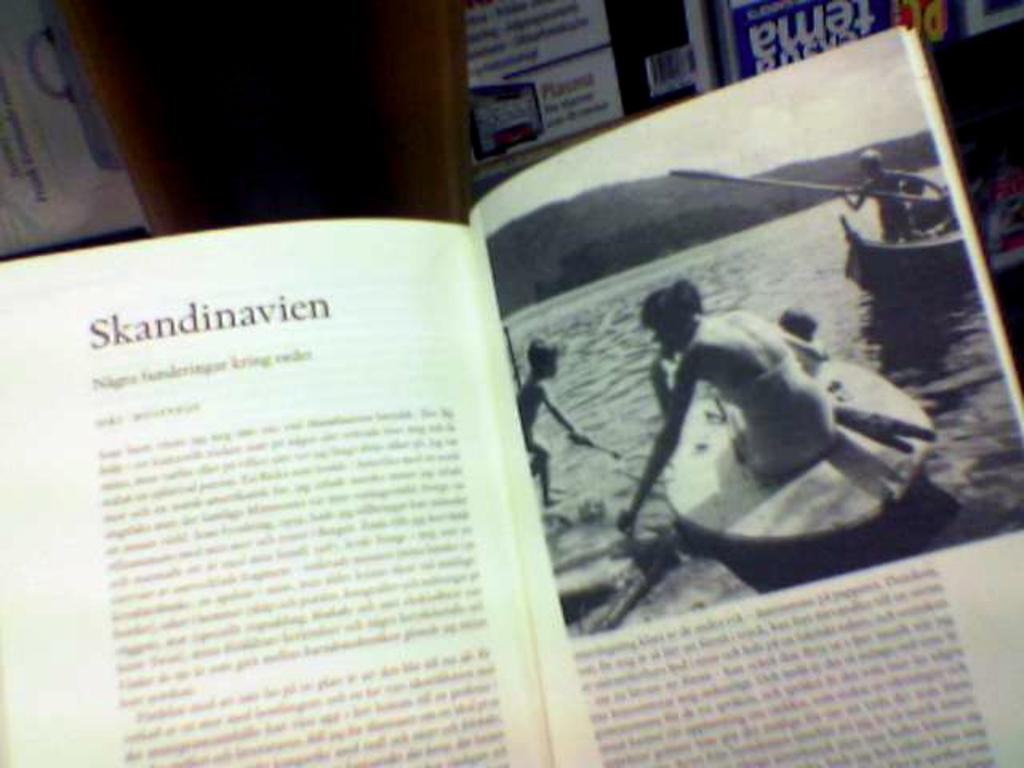<image>
Give a short and clear explanation of the subsequent image. A book open to a page with a woman and a title called Skandinavien. 